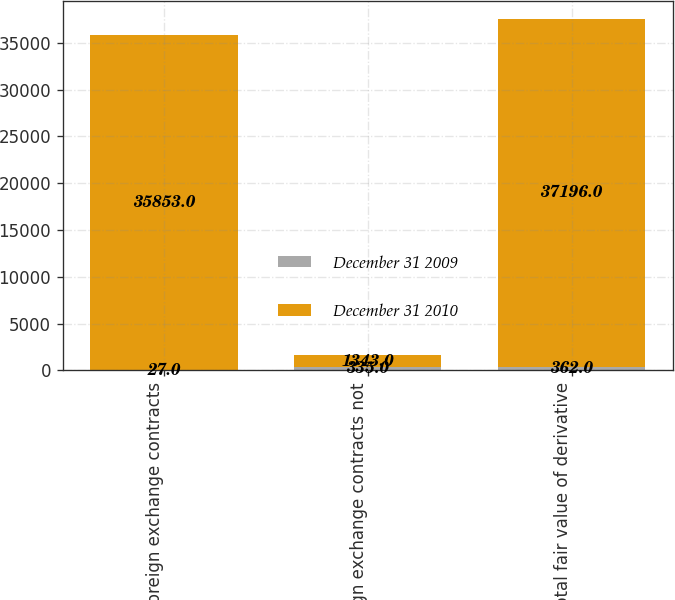<chart> <loc_0><loc_0><loc_500><loc_500><stacked_bar_chart><ecel><fcel>Foreign exchange contracts<fcel>Foreign exchange contracts not<fcel>Total fair value of derivative<nl><fcel>December 31 2009<fcel>27<fcel>335<fcel>362<nl><fcel>December 31 2010<fcel>35853<fcel>1343<fcel>37196<nl></chart> 